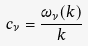Convert formula to latex. <formula><loc_0><loc_0><loc_500><loc_500>c _ { \nu } = \frac { \omega _ { \nu } ( k ) } { k }</formula> 